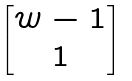Convert formula to latex. <formula><loc_0><loc_0><loc_500><loc_500>\begin{bmatrix} w - 1 \\ 1 \end{bmatrix}</formula> 